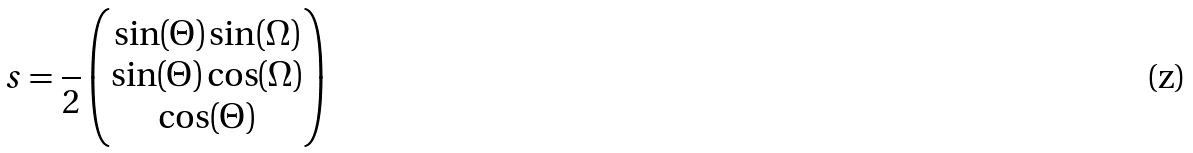<formula> <loc_0><loc_0><loc_500><loc_500>s = { { \frac { } { 2 } } } \begin{pmatrix} \sin ( \Theta ) \sin ( \Omega ) \\ \sin ( \Theta ) \cos ( \Omega ) \\ \cos ( \Theta ) \end{pmatrix}</formula> 